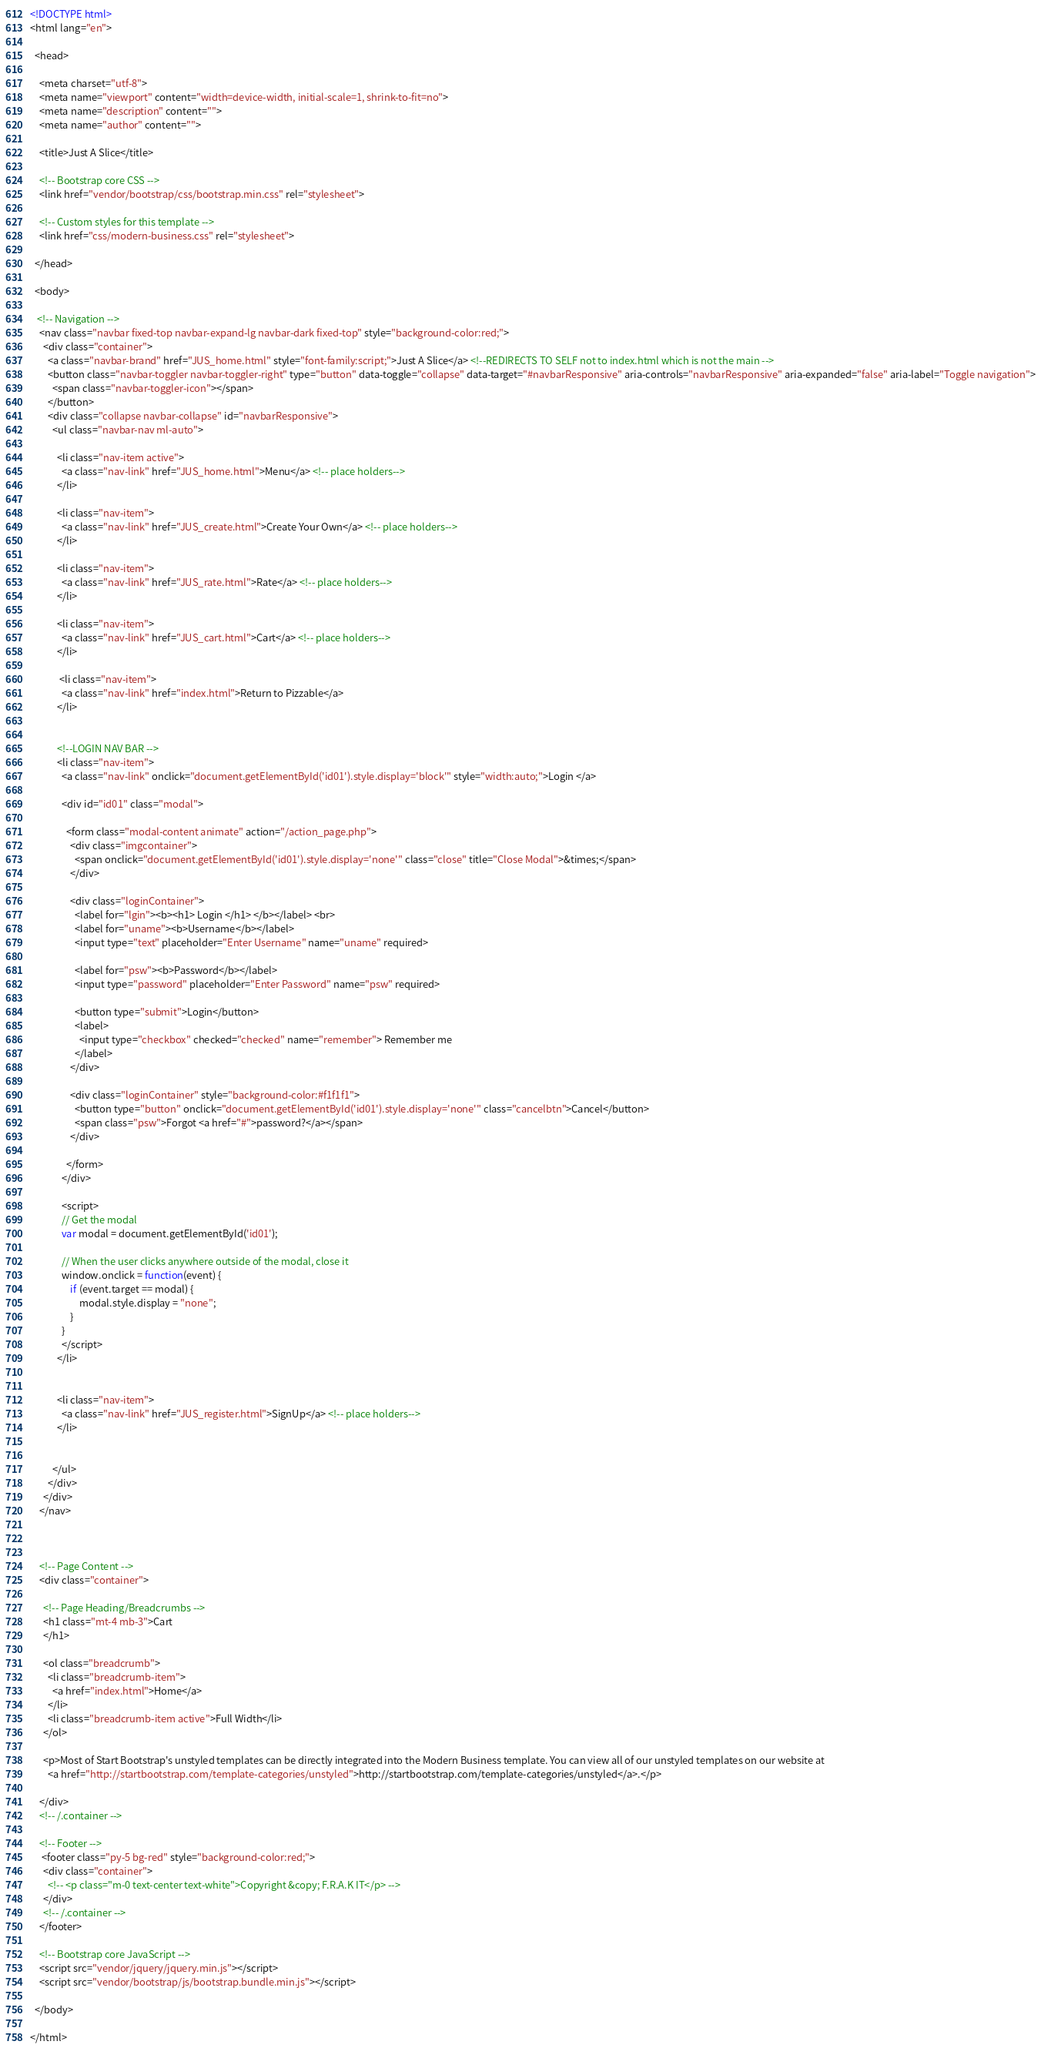<code> <loc_0><loc_0><loc_500><loc_500><_HTML_><!DOCTYPE html>
<html lang="en">

  <head>

    <meta charset="utf-8">
    <meta name="viewport" content="width=device-width, initial-scale=1, shrink-to-fit=no">
    <meta name="description" content="">
    <meta name="author" content="">

    <title>Just A Slice</title>

    <!-- Bootstrap core CSS -->
    <link href="vendor/bootstrap/css/bootstrap.min.css" rel="stylesheet">

    <!-- Custom styles for this template -->
    <link href="css/modern-business.css" rel="stylesheet">

  </head>

  <body>

   <!-- Navigation -->
    <nav class="navbar fixed-top navbar-expand-lg navbar-dark fixed-top" style="background-color:red;">
      <div class="container">
        <a class="navbar-brand" href="JUS_home.html" style="font-family:script;">Just A Slice</a> <!--REDIRECTS TO SELF not to index.html which is not the main -->
        <button class="navbar-toggler navbar-toggler-right" type="button" data-toggle="collapse" data-target="#navbarResponsive" aria-controls="navbarResponsive" aria-expanded="false" aria-label="Toggle navigation">
          <span class="navbar-toggler-icon"></span>
        </button>
        <div class="collapse navbar-collapse" id="navbarResponsive">
          <ul class="navbar-nav ml-auto">

            <li class="nav-item active">
              <a class="nav-link" href="JUS_home.html">Menu</a> <!-- place holders-->
            </li>

            <li class="nav-item">
              <a class="nav-link" href="JUS_create.html">Create Your Own</a> <!-- place holders-->
            </li>

            <li class="nav-item">
              <a class="nav-link" href="JUS_rate.html">Rate</a> <!-- place holders-->
            </li>

            <li class="nav-item">
              <a class="nav-link" href="JUS_cart.html">Cart</a> <!-- place holders-->
            </li>

             <li class="nav-item">
              <a class="nav-link" href="index.html">Return to Pizzable</a>
            </li>

          
            <!--LOGIN NAV BAR -->
            <li class="nav-item">
              <a class="nav-link" onclick="document.getElementById('id01').style.display='block'" style="width:auto;">Login </a>

              <div id="id01" class="modal">
                
                <form class="modal-content animate" action="/action_page.php">
                  <div class="imgcontainer">
                    <span onclick="document.getElementById('id01').style.display='none'" class="close" title="Close Modal">&times;</span>
                  </div>

                  <div class="loginContainer">
                    <label for="lgin"><b><h1> Login </h1> </b></label> <br>
                    <label for="uname"><b>Username</b></label>
                    <input type="text" placeholder="Enter Username" name="uname" required>

                    <label for="psw"><b>Password</b></label>
                    <input type="password" placeholder="Enter Password" name="psw" required>
                      
                    <button type="submit">Login</button>
                    <label>
                      <input type="checkbox" checked="checked" name="remember"> Remember me
                    </label>
                  </div>

                  <div class="loginContainer" style="background-color:#f1f1f1">
                    <button type="button" onclick="document.getElementById('id01').style.display='none'" class="cancelbtn">Cancel</button>
                    <span class="psw">Forgot <a href="#">password?</a></span>
                  </div>

                </form>
              </div>

              <script>
              // Get the modal
              var modal = document.getElementById('id01');

              // When the user clicks anywhere outside of the modal, close it
              window.onclick = function(event) {
                  if (event.target == modal) {
                      modal.style.display = "none";
                  }
              }
              </script>
            </li>


            <li class="nav-item">
              <a class="nav-link" href="JUS_register.html">SignUp</a> <!-- place holders-->
            </li>


          </ul>
        </div>
      </div>
    </nav>



    <!-- Page Content -->
    <div class="container">

      <!-- Page Heading/Breadcrumbs -->
      <h1 class="mt-4 mb-3">Cart 
      </h1>

      <ol class="breadcrumb">
        <li class="breadcrumb-item">
          <a href="index.html">Home</a>
        </li>
        <li class="breadcrumb-item active">Full Width</li>
      </ol>

      <p>Most of Start Bootstrap's unstyled templates can be directly integrated into the Modern Business template. You can view all of our unstyled templates on our website at
        <a href="http://startbootstrap.com/template-categories/unstyled">http://startbootstrap.com/template-categories/unstyled</a>.</p>

    </div>
    <!-- /.container -->

    <!-- Footer -->
     <footer class="py-5 bg-red" style="background-color:red;">
      <div class="container">
        <!-- <p class="m-0 text-center text-white">Copyright &copy; F.R.A.K IT</p> -->
      </div>
      <!-- /.container -->
    </footer>

    <!-- Bootstrap core JavaScript -->
    <script src="vendor/jquery/jquery.min.js"></script>
    <script src="vendor/bootstrap/js/bootstrap.bundle.min.js"></script>

  </body>

</html>
</code> 